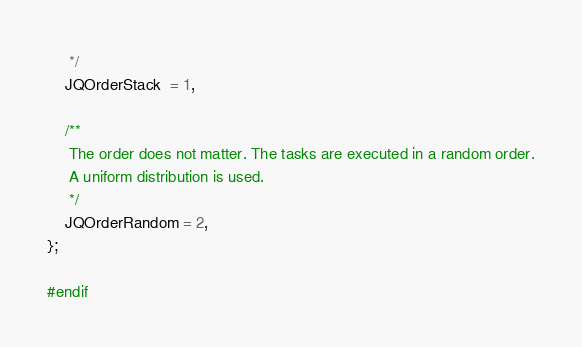Convert code to text. <code><loc_0><loc_0><loc_500><loc_500><_C_>     */
    JQOrderStack  = 1,
    
    /**
     The order does not matter. The tasks are executed in a random order.
     A uniform distribution is used.
     */
    JQOrderRandom = 2,
};

#endif
</code> 